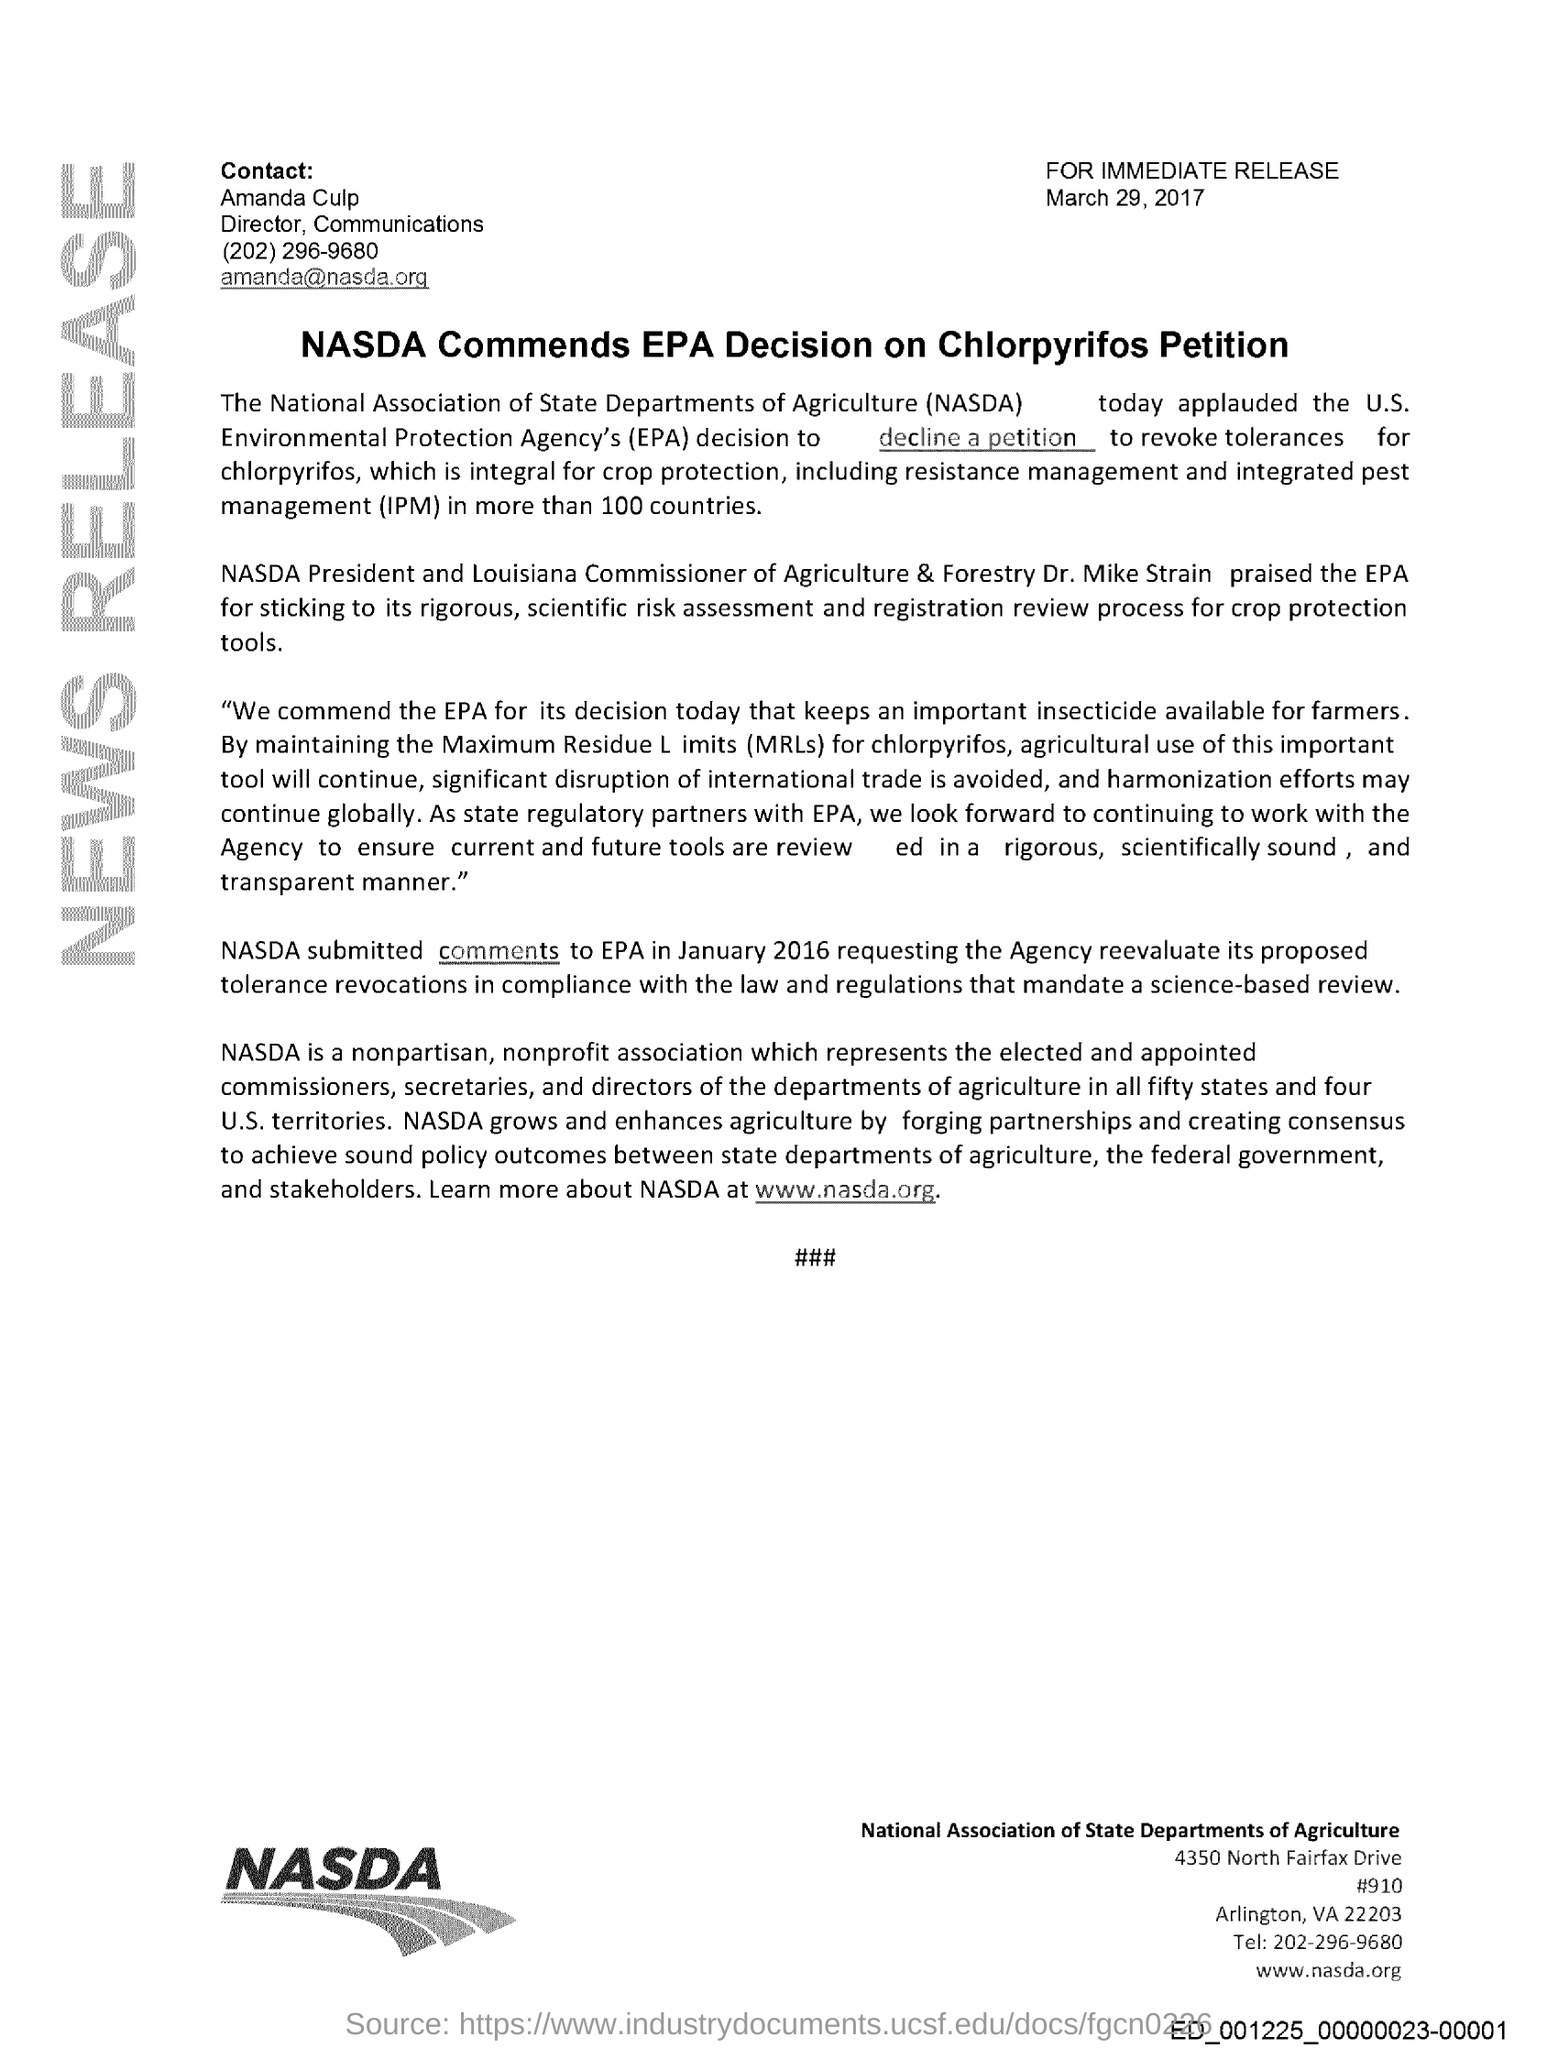What is the fullform of NASDA?
Your answer should be compact. National Association of State Departments of Agriculture. When did NASDA submitted comments to EPA?
Your response must be concise. January 2016. What is the issued date of this document?
Provide a short and direct response. March 29 , 2017. Who is the Louisiana Commissioner of Agriculture & Forestry?
Offer a very short reply. Dr. Mike Strain. 